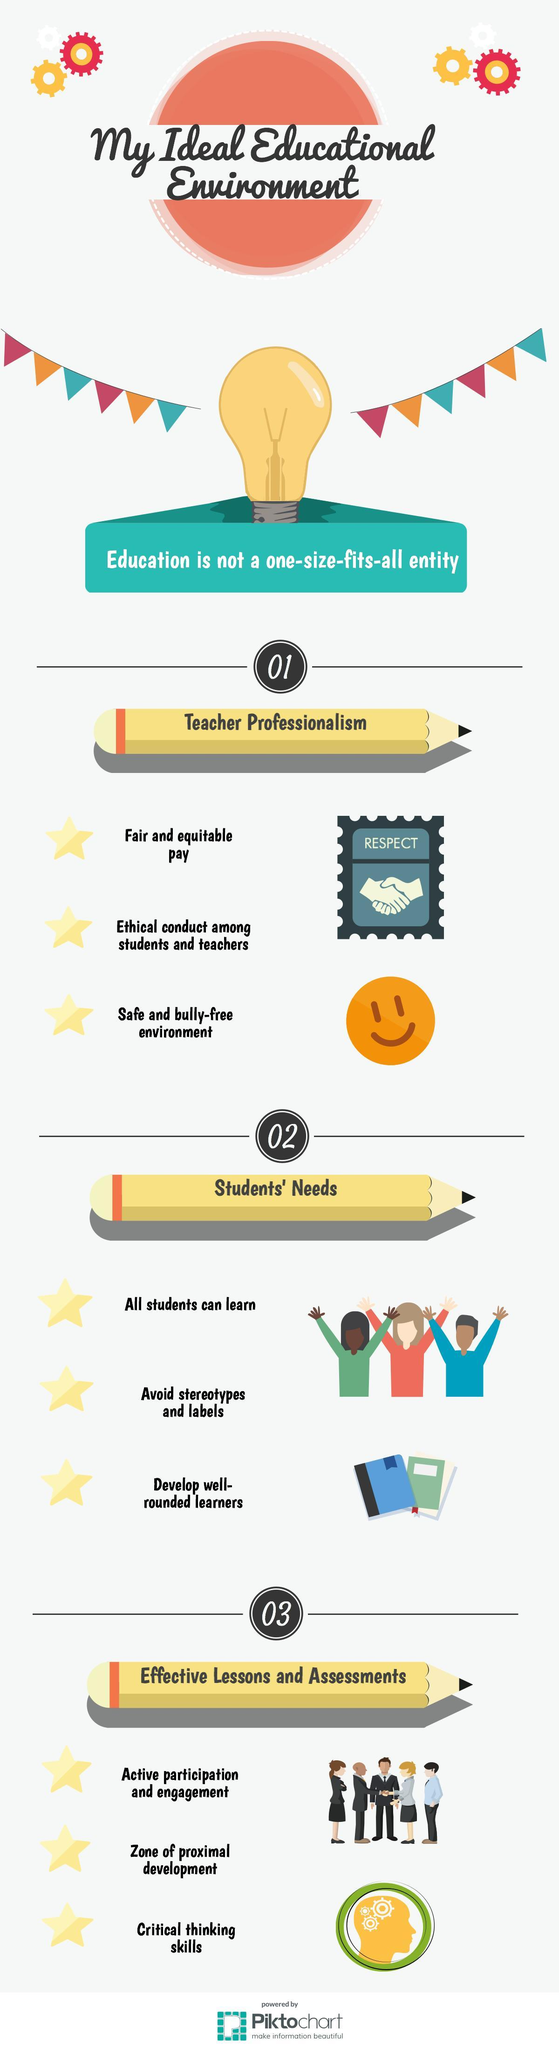Outline some significant characteristics in this image. Both students and teachers should promote ethical conduct amongst themselves by showing respect towards one another. 